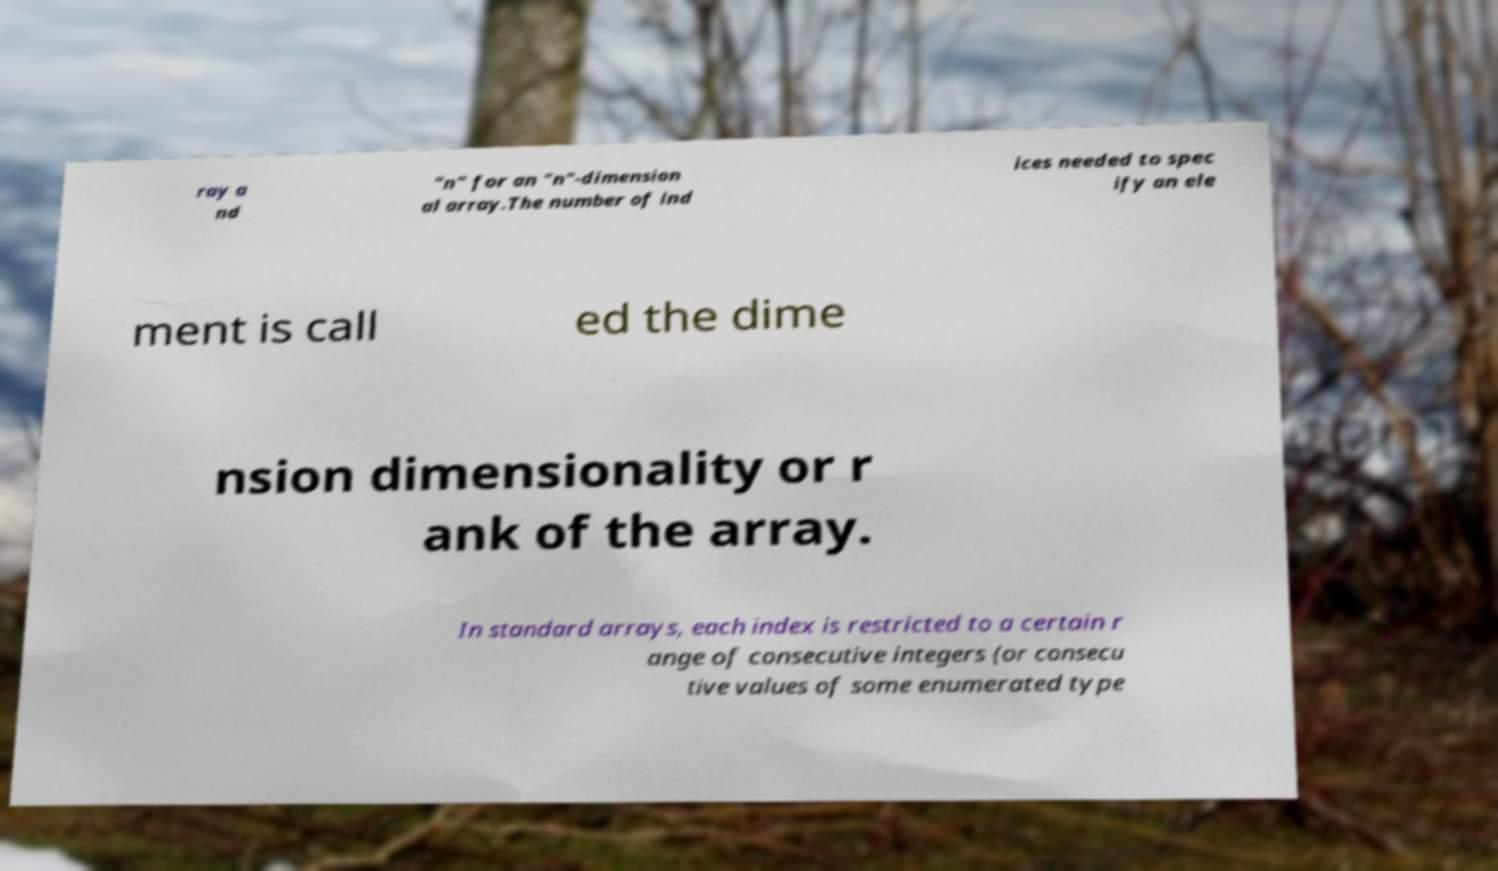Can you accurately transcribe the text from the provided image for me? ray a nd "n" for an "n"-dimension al array.The number of ind ices needed to spec ify an ele ment is call ed the dime nsion dimensionality or r ank of the array. In standard arrays, each index is restricted to a certain r ange of consecutive integers (or consecu tive values of some enumerated type 